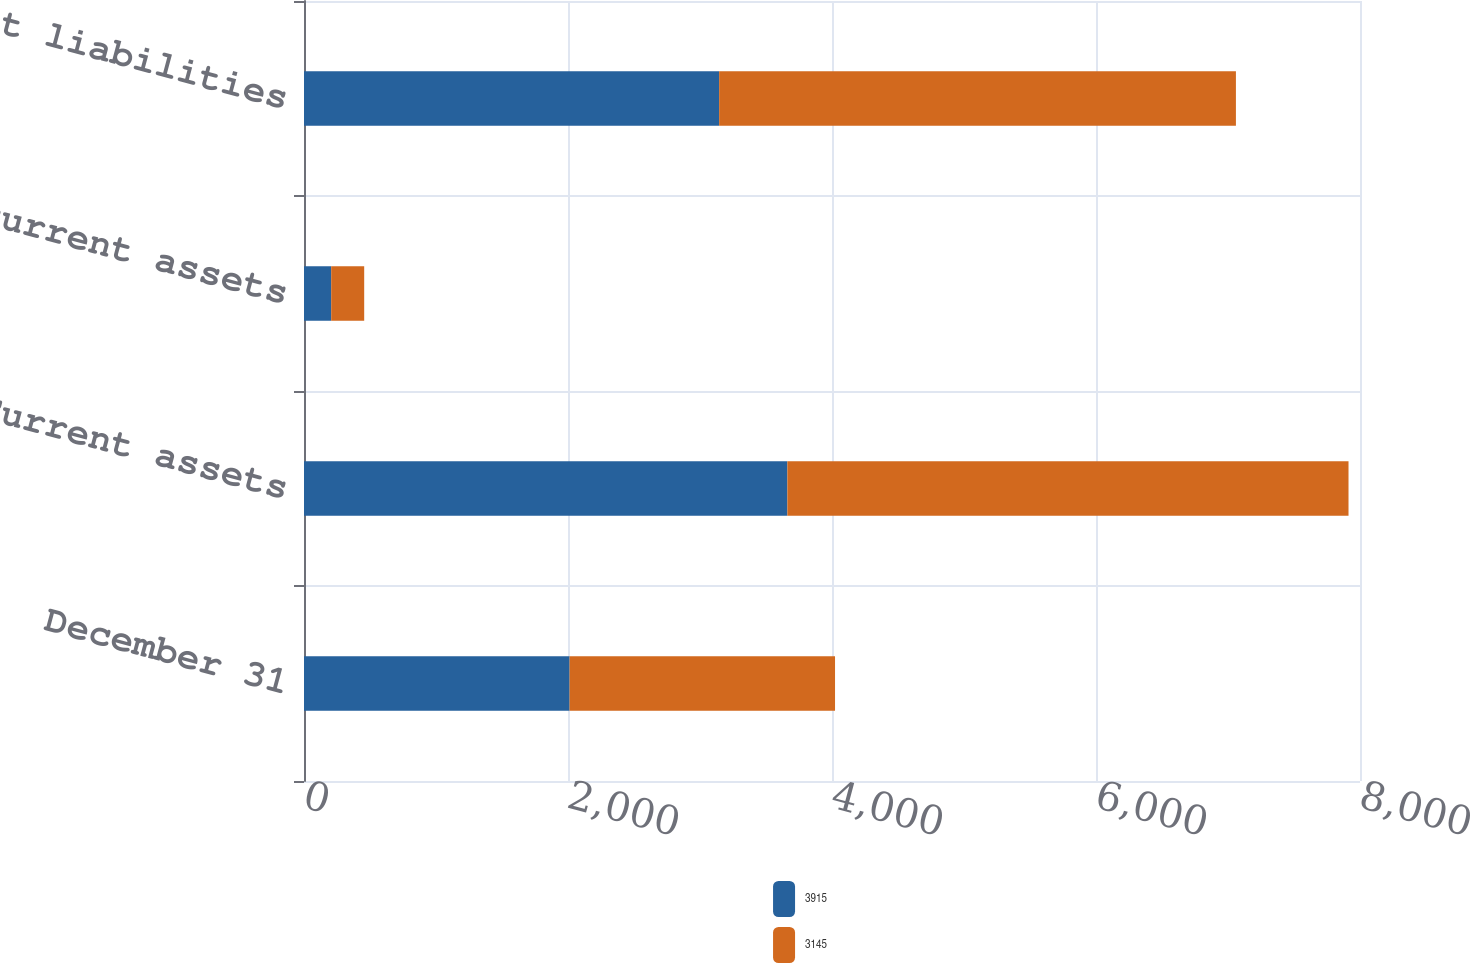Convert chart. <chart><loc_0><loc_0><loc_500><loc_500><stacked_bar_chart><ecel><fcel>December 31<fcel>Current assets<fcel>Noncurrent assets<fcel>Current liabilities<nl><fcel>3915<fcel>2012<fcel>3662<fcel>206<fcel>3145<nl><fcel>3145<fcel>2011<fcel>4251<fcel>250<fcel>3915<nl></chart> 